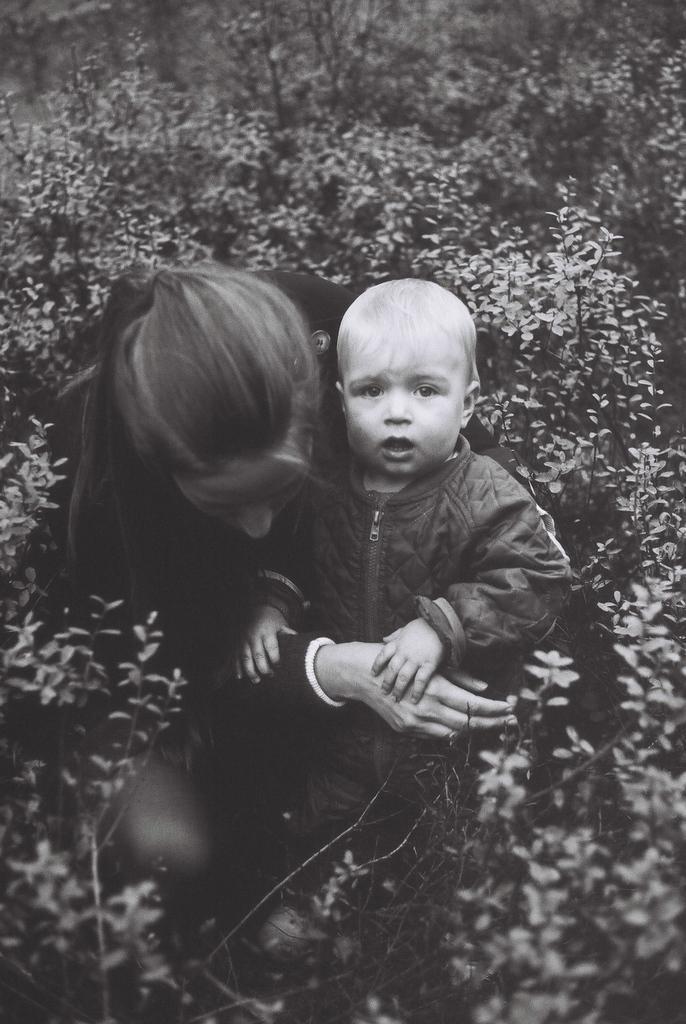Can you describe this image briefly? In this image we can see a lady persons wearing black color dress holding kid in her hands who is wearing black color dress and at the background of the image there are some flowers and plants. 